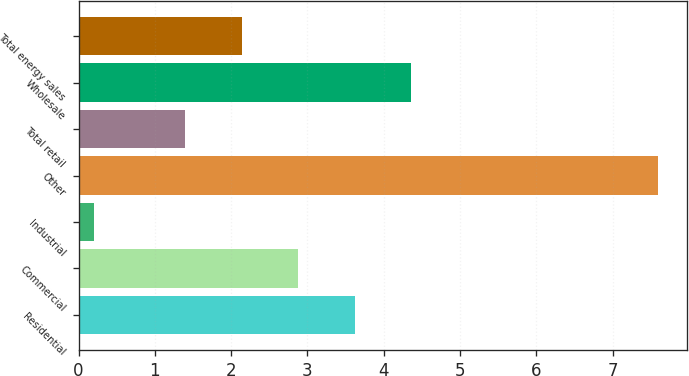Convert chart to OTSL. <chart><loc_0><loc_0><loc_500><loc_500><bar_chart><fcel>Residential<fcel>Commercial<fcel>Industrial<fcel>Other<fcel>Total retail<fcel>Wholesale<fcel>Total energy sales<nl><fcel>3.62<fcel>2.88<fcel>0.2<fcel>7.6<fcel>1.4<fcel>4.36<fcel>2.14<nl></chart> 